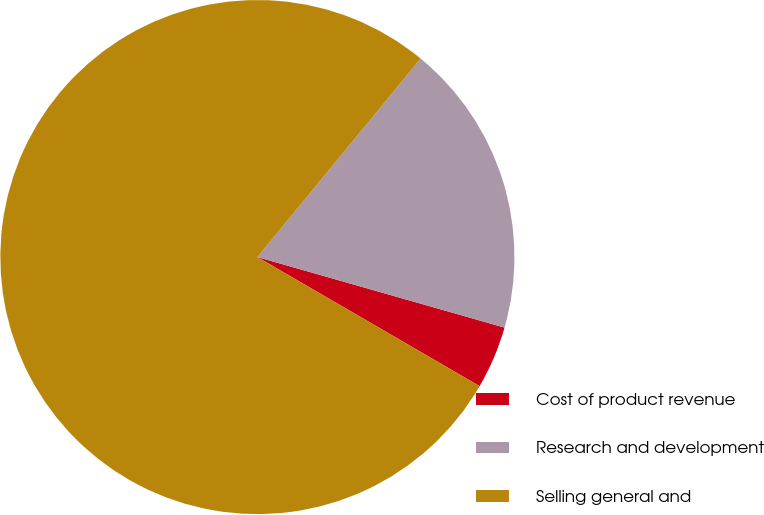Convert chart. <chart><loc_0><loc_0><loc_500><loc_500><pie_chart><fcel>Cost of product revenue<fcel>Research and development<fcel>Selling general and<nl><fcel>3.95%<fcel>18.47%<fcel>77.59%<nl></chart> 